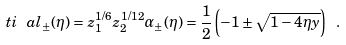Convert formula to latex. <formula><loc_0><loc_0><loc_500><loc_500>\ t i \ a l _ { \pm } ( \eta ) = z _ { 1 } ^ { 1 / 6 } z _ { 2 } ^ { 1 / 1 2 } \alpha _ { \pm } ( \eta ) = \frac { 1 } { 2 } \left ( - 1 \pm \sqrt { 1 - 4 \eta y } \right ) \ .</formula> 